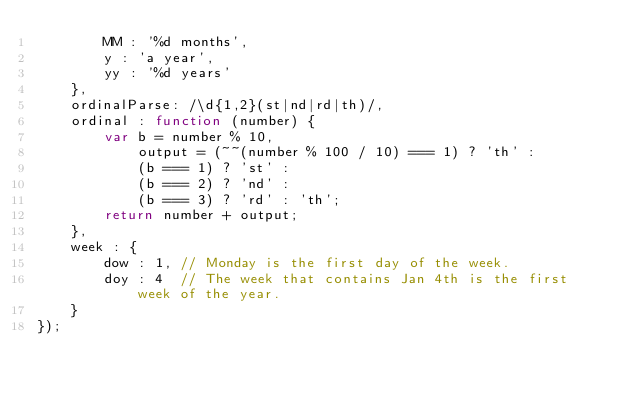Convert code to text. <code><loc_0><loc_0><loc_500><loc_500><_JavaScript_>        MM : '%d months',
        y : 'a year',
        yy : '%d years'
    },
    ordinalParse: /\d{1,2}(st|nd|rd|th)/,
    ordinal : function (number) {
        var b = number % 10,
            output = (~~(number % 100 / 10) === 1) ? 'th' :
            (b === 1) ? 'st' :
            (b === 2) ? 'nd' :
            (b === 3) ? 'rd' : 'th';
        return number + output;
    },
    week : {
        dow : 1, // Monday is the first day of the week.
        doy : 4  // The week that contains Jan 4th is the first week of the year.
    }
});
</code> 